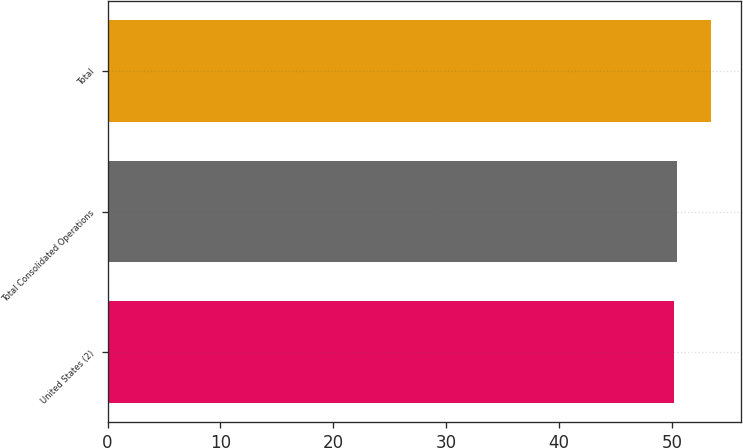Convert chart to OTSL. <chart><loc_0><loc_0><loc_500><loc_500><bar_chart><fcel>United States (2)<fcel>Total Consolidated Operations<fcel>Total<nl><fcel>50.15<fcel>50.48<fcel>53.45<nl></chart> 